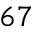Convert formula to latex. <formula><loc_0><loc_0><loc_500><loc_500>6 7</formula> 